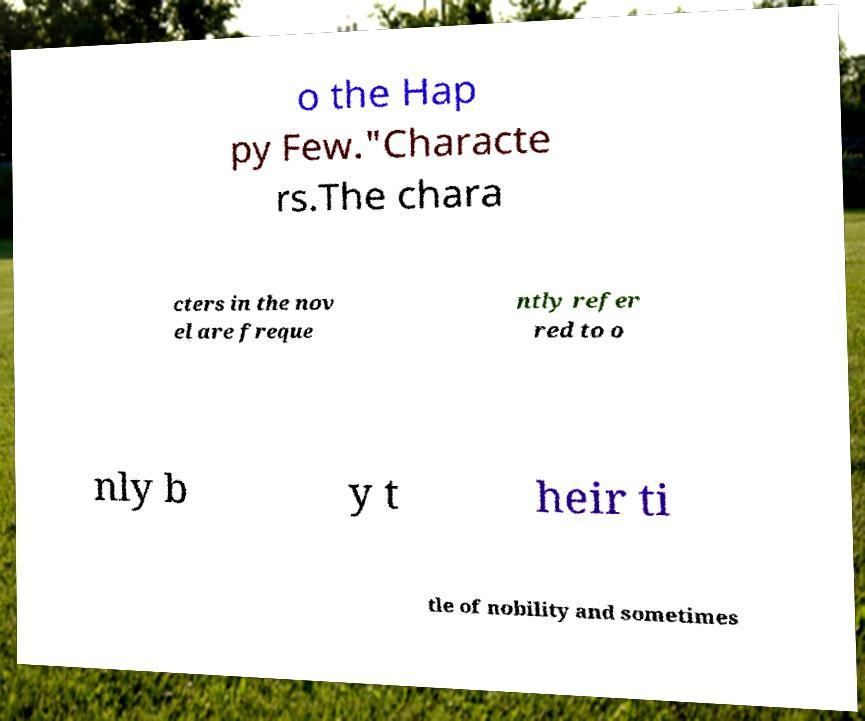There's text embedded in this image that I need extracted. Can you transcribe it verbatim? o the Hap py Few."Characte rs.The chara cters in the nov el are freque ntly refer red to o nly b y t heir ti tle of nobility and sometimes 